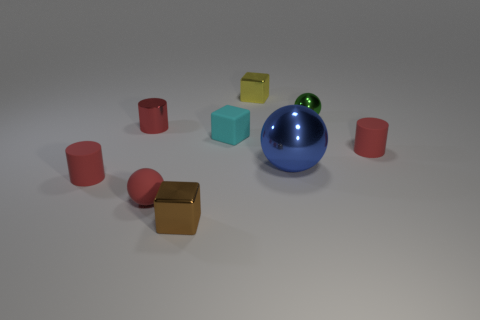What number of green metal objects are there?
Your response must be concise. 1. What is the size of the red object that is in front of the small red rubber cylinder that is on the left side of the tiny ball that is behind the small matte sphere?
Keep it short and to the point. Small. Is the big metallic object the same color as the matte block?
Your response must be concise. No. Are there any other things that are the same size as the green shiny thing?
Ensure brevity in your answer.  Yes. How many small red metallic things are on the left side of the big metal thing?
Your answer should be very brief. 1. Are there the same number of green things on the right side of the brown metallic object and large brown matte cubes?
Provide a succinct answer. No. How many objects are either blue metallic things or tiny yellow blocks?
Offer a terse response. 2. Is there anything else that is the same shape as the tiny yellow metallic object?
Ensure brevity in your answer.  Yes. There is a red matte object that is behind the small red rubber cylinder on the left side of the blue shiny sphere; what is its shape?
Ensure brevity in your answer.  Cylinder. What is the shape of the tiny brown object that is made of the same material as the tiny green thing?
Provide a short and direct response. Cube. 